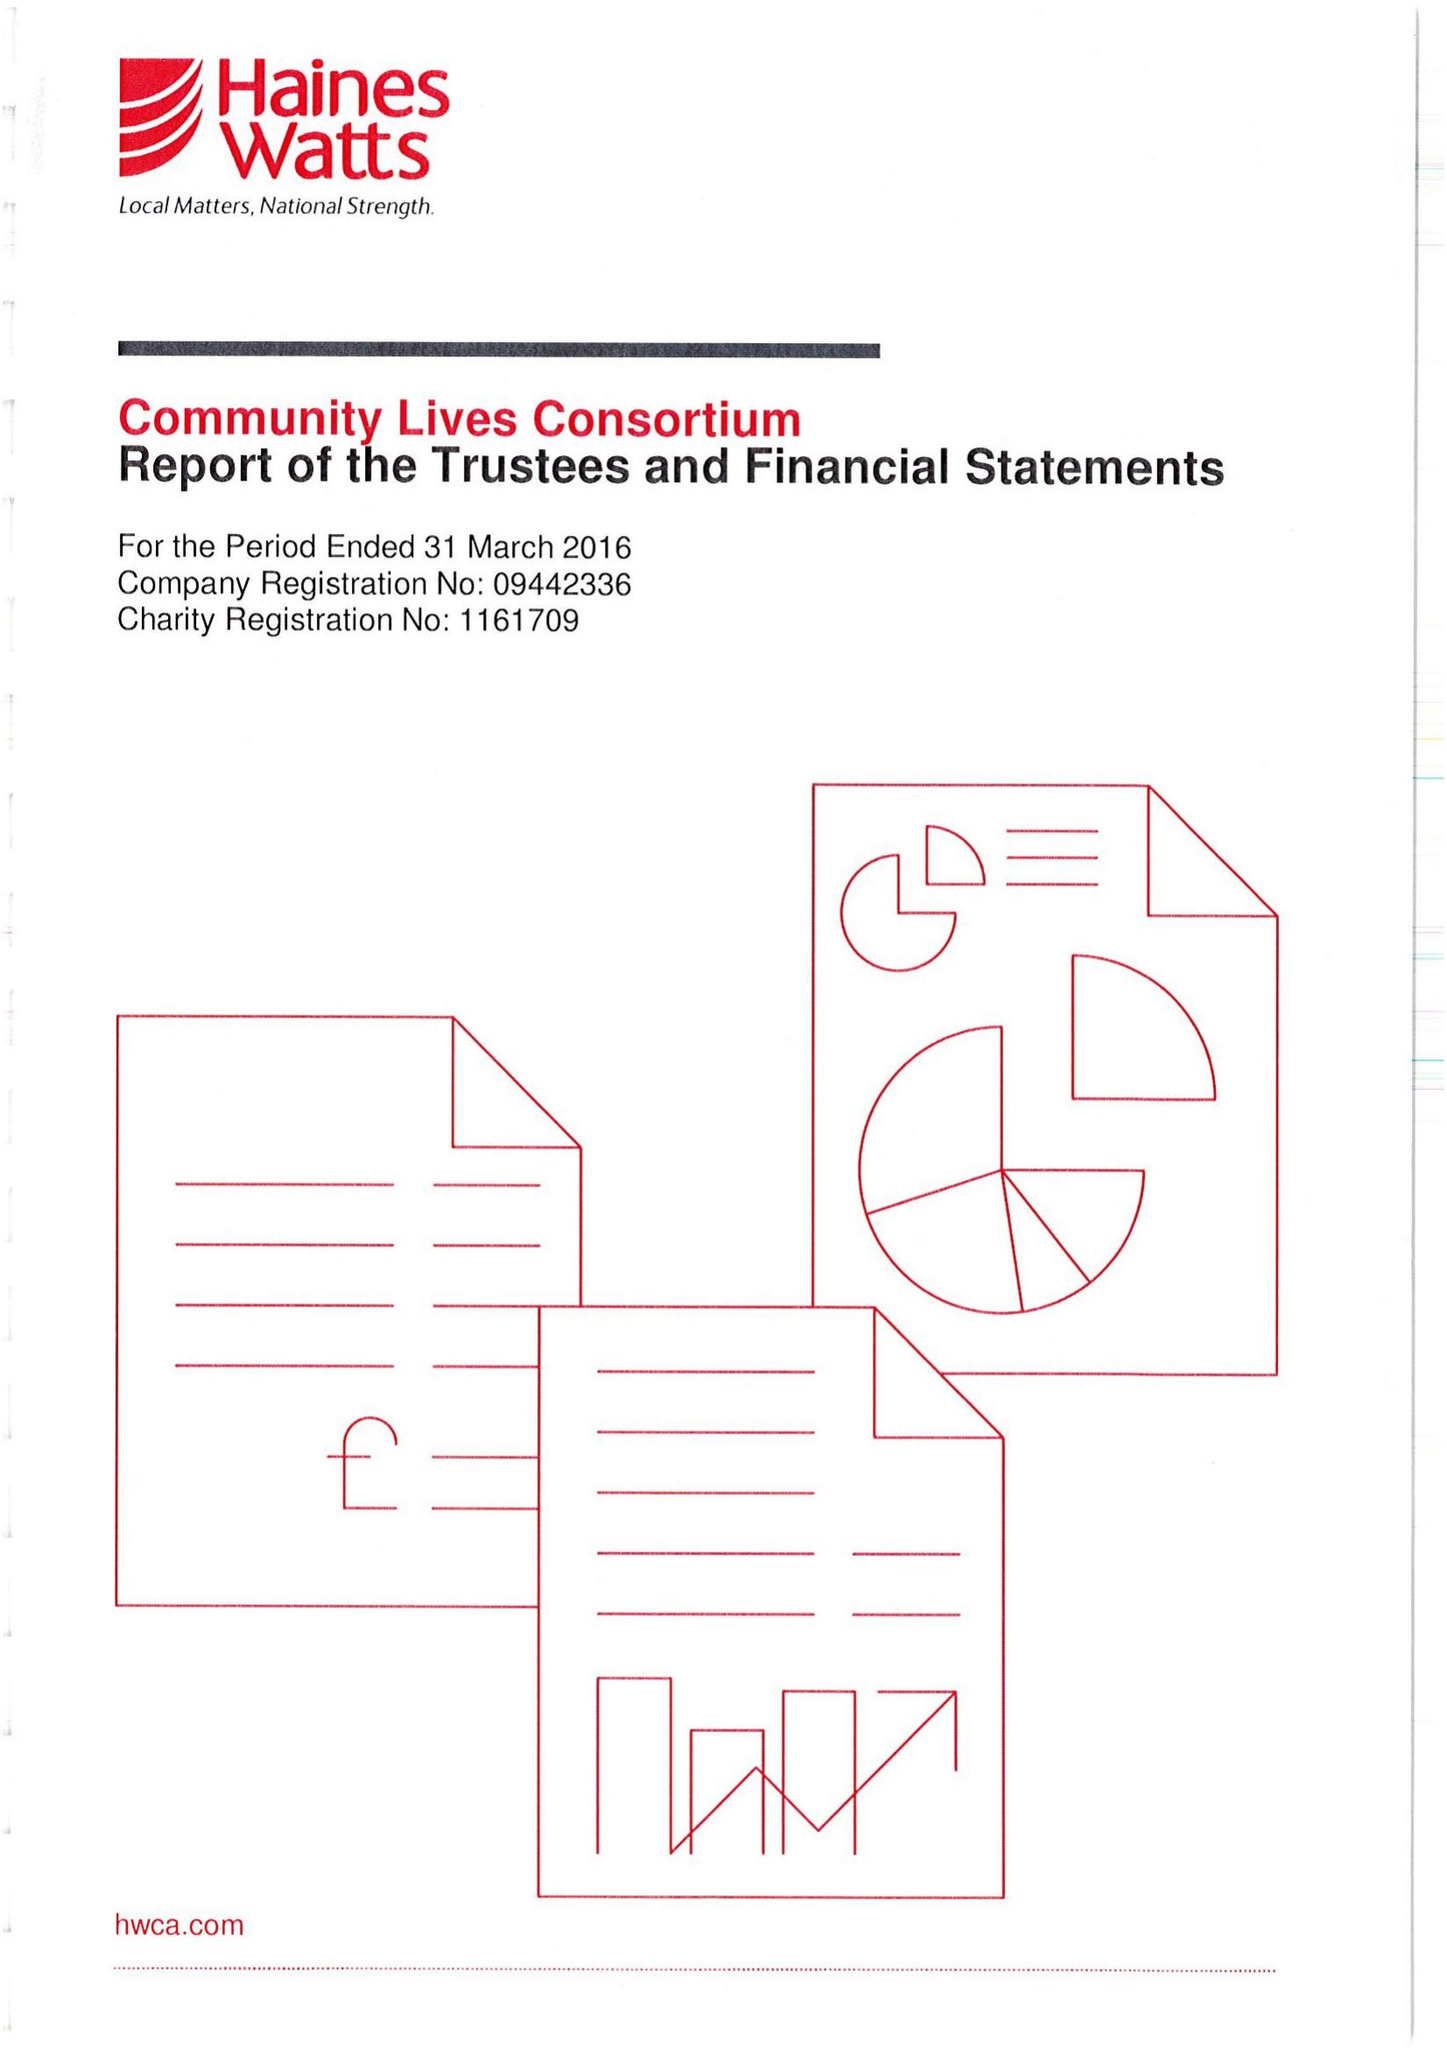What is the value for the report_date?
Answer the question using a single word or phrase. 2016-03-31 